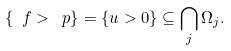<formula> <loc_0><loc_0><loc_500><loc_500>\{ \ f > \ p \} = \{ u > 0 \} \subseteq \bigcap _ { j } \Omega _ { j } .</formula> 